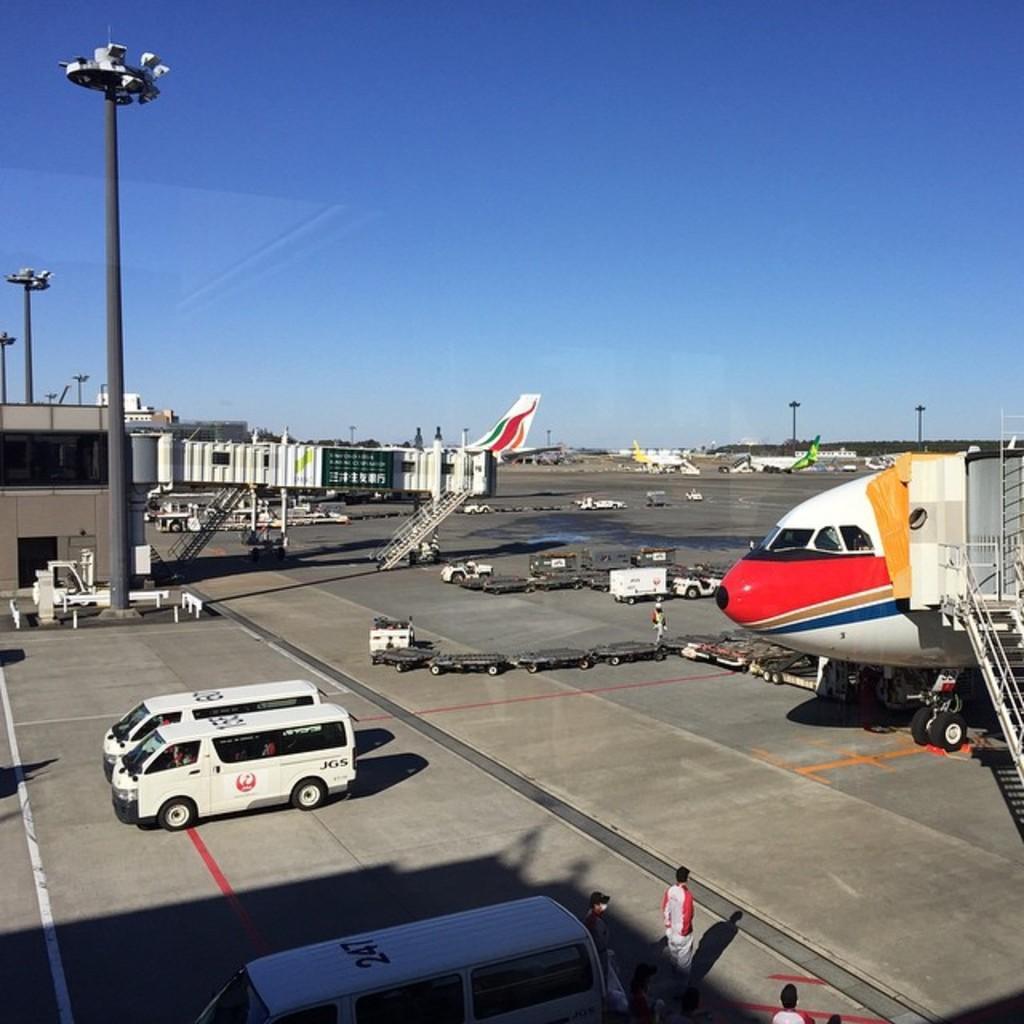Please provide a concise description of this image. This image is taken in the airport. In this image we can see aeroplanes, run way, light poles, vehicles, persons, trees and sky. 